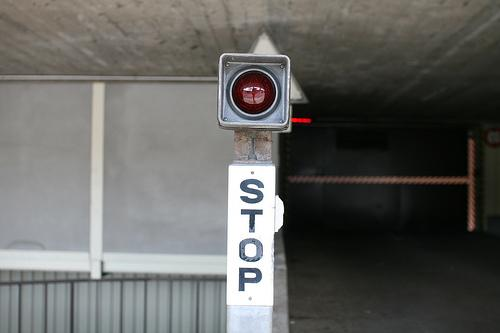Explain the appearance of the ceiling in the image. The ceiling in the image is concrete gray with grooves and extends across the area. Provide a brief description of the post with a light on it. The post is a vertical structure with a round red light on it, and there's a white sign with black writings on it. Mention any object or structure related to traffic regulation in the image. There is a cameralike traffic light and a vertical white stop sign related to traffic regulation in the image. Provide information about the sign with black letters in the image. The sign is white with black letters on it, located on a post, and it has a vertical white stripe. What kind of road is shown in the image? A gray concrete road is shown in the image. Can you count the small iron fence posts in the image and provide the number? There are 7 small iron fence posts in the image. Identify any fencing or barrier structures in the image. There is a metal pole barrier and thin metal spokes of a railing are present as fencing structures in the image. Describe any visible effects of wear or aging on objects in the image. There is paint peeling off a post in the image, indicating wear and aging. What type of wall can be seen in the background of the image? The wall in the background is a grey wall of a building. What is the predominant color of the light in the image? The predominant color of the light in the image is red. 